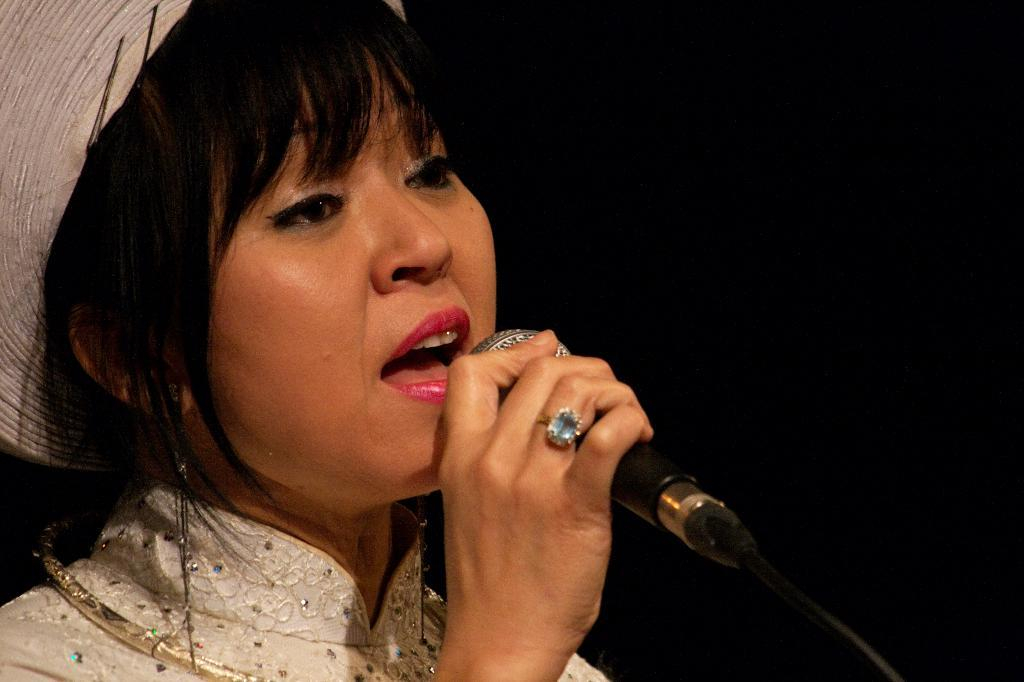Who is the main subject in the image? There is a lady in the image. What is the lady holding in the image? The lady is holding a mic. What color is the background of the image? The background of the image is black. How does the lady react to the feeling of shame in the image? There is no indication of shame or any reaction to it in the image; the lady is simply holding a mic. 